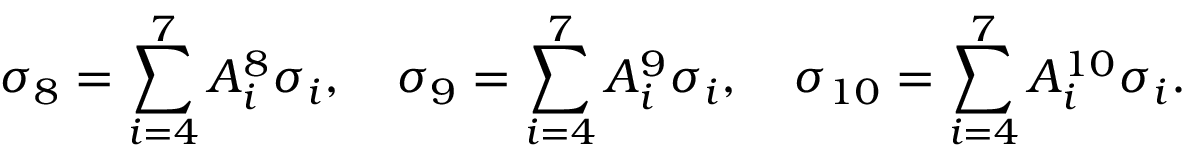<formula> <loc_0><loc_0><loc_500><loc_500>\sigma _ { 8 } = \sum _ { i = 4 } ^ { 7 } A _ { i } ^ { 8 } \sigma _ { i } , \quad \sigma _ { 9 } = \sum _ { i = 4 } ^ { 7 } A _ { i } ^ { 9 } \sigma _ { i } , \quad \sigma _ { 1 0 } = \sum _ { i = 4 } ^ { 7 } A _ { i } ^ { 1 0 } \sigma _ { i } .</formula> 